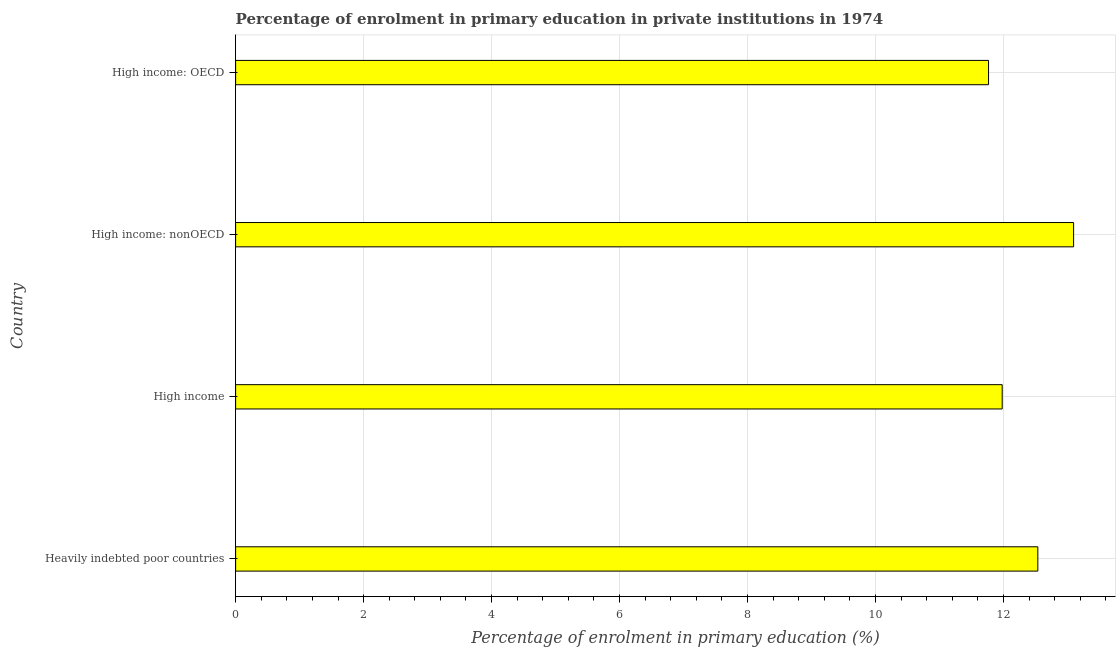Does the graph contain any zero values?
Offer a terse response. No. What is the title of the graph?
Make the answer very short. Percentage of enrolment in primary education in private institutions in 1974. What is the label or title of the X-axis?
Offer a very short reply. Percentage of enrolment in primary education (%). What is the enrolment percentage in primary education in Heavily indebted poor countries?
Offer a very short reply. 12.54. Across all countries, what is the maximum enrolment percentage in primary education?
Your answer should be compact. 13.1. Across all countries, what is the minimum enrolment percentage in primary education?
Make the answer very short. 11.77. In which country was the enrolment percentage in primary education maximum?
Provide a succinct answer. High income: nonOECD. In which country was the enrolment percentage in primary education minimum?
Offer a terse response. High income: OECD. What is the sum of the enrolment percentage in primary education?
Give a very brief answer. 49.38. What is the difference between the enrolment percentage in primary education in High income: OECD and High income: nonOECD?
Your response must be concise. -1.33. What is the average enrolment percentage in primary education per country?
Ensure brevity in your answer.  12.34. What is the median enrolment percentage in primary education?
Ensure brevity in your answer.  12.26. In how many countries, is the enrolment percentage in primary education greater than 11.2 %?
Provide a succinct answer. 4. What is the ratio of the enrolment percentage in primary education in Heavily indebted poor countries to that in High income: OECD?
Offer a very short reply. 1.06. Is the difference between the enrolment percentage in primary education in High income and High income: OECD greater than the difference between any two countries?
Offer a terse response. No. What is the difference between the highest and the second highest enrolment percentage in primary education?
Offer a very short reply. 0.56. Is the sum of the enrolment percentage in primary education in High income and High income: nonOECD greater than the maximum enrolment percentage in primary education across all countries?
Provide a succinct answer. Yes. What is the difference between the highest and the lowest enrolment percentage in primary education?
Give a very brief answer. 1.33. What is the Percentage of enrolment in primary education (%) in Heavily indebted poor countries?
Offer a terse response. 12.54. What is the Percentage of enrolment in primary education (%) in High income?
Ensure brevity in your answer.  11.98. What is the Percentage of enrolment in primary education (%) in High income: nonOECD?
Make the answer very short. 13.1. What is the Percentage of enrolment in primary education (%) of High income: OECD?
Offer a very short reply. 11.77. What is the difference between the Percentage of enrolment in primary education (%) in Heavily indebted poor countries and High income?
Provide a short and direct response. 0.56. What is the difference between the Percentage of enrolment in primary education (%) in Heavily indebted poor countries and High income: nonOECD?
Give a very brief answer. -0.56. What is the difference between the Percentage of enrolment in primary education (%) in Heavily indebted poor countries and High income: OECD?
Keep it short and to the point. 0.77. What is the difference between the Percentage of enrolment in primary education (%) in High income and High income: nonOECD?
Provide a succinct answer. -1.12. What is the difference between the Percentage of enrolment in primary education (%) in High income and High income: OECD?
Ensure brevity in your answer.  0.21. What is the difference between the Percentage of enrolment in primary education (%) in High income: nonOECD and High income: OECD?
Offer a terse response. 1.33. What is the ratio of the Percentage of enrolment in primary education (%) in Heavily indebted poor countries to that in High income?
Your answer should be very brief. 1.05. What is the ratio of the Percentage of enrolment in primary education (%) in Heavily indebted poor countries to that in High income: OECD?
Give a very brief answer. 1.06. What is the ratio of the Percentage of enrolment in primary education (%) in High income to that in High income: nonOECD?
Your answer should be very brief. 0.92. What is the ratio of the Percentage of enrolment in primary education (%) in High income to that in High income: OECD?
Provide a succinct answer. 1.02. What is the ratio of the Percentage of enrolment in primary education (%) in High income: nonOECD to that in High income: OECD?
Offer a terse response. 1.11. 